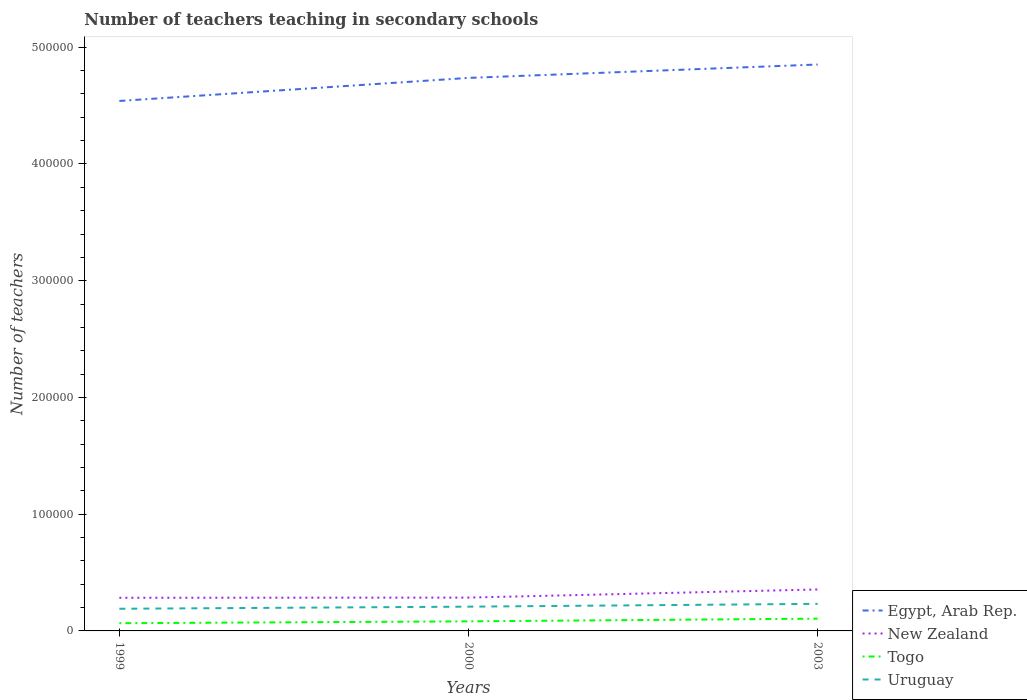How many different coloured lines are there?
Your answer should be compact. 4. Does the line corresponding to Togo intersect with the line corresponding to New Zealand?
Provide a succinct answer. No. Is the number of lines equal to the number of legend labels?
Your answer should be very brief. Yes. Across all years, what is the maximum number of teachers teaching in secondary schools in Togo?
Ensure brevity in your answer.  6595. In which year was the number of teachers teaching in secondary schools in New Zealand maximum?
Give a very brief answer. 1999. What is the total number of teachers teaching in secondary schools in Togo in the graph?
Your response must be concise. -1608. What is the difference between the highest and the second highest number of teachers teaching in secondary schools in Uruguay?
Offer a very short reply. 4207. Is the number of teachers teaching in secondary schools in Uruguay strictly greater than the number of teachers teaching in secondary schools in New Zealand over the years?
Provide a succinct answer. Yes. How many years are there in the graph?
Your answer should be compact. 3. What is the difference between two consecutive major ticks on the Y-axis?
Make the answer very short. 1.00e+05. Are the values on the major ticks of Y-axis written in scientific E-notation?
Your response must be concise. No. Does the graph contain any zero values?
Offer a terse response. No. Does the graph contain grids?
Offer a very short reply. No. How many legend labels are there?
Your answer should be compact. 4. How are the legend labels stacked?
Ensure brevity in your answer.  Vertical. What is the title of the graph?
Your answer should be very brief. Number of teachers teaching in secondary schools. What is the label or title of the X-axis?
Offer a terse response. Years. What is the label or title of the Y-axis?
Your response must be concise. Number of teachers. What is the Number of teachers of Egypt, Arab Rep. in 1999?
Ensure brevity in your answer.  4.54e+05. What is the Number of teachers in New Zealand in 1999?
Make the answer very short. 2.84e+04. What is the Number of teachers of Togo in 1999?
Ensure brevity in your answer.  6595. What is the Number of teachers in Uruguay in 1999?
Ensure brevity in your answer.  1.90e+04. What is the Number of teachers of Egypt, Arab Rep. in 2000?
Make the answer very short. 4.74e+05. What is the Number of teachers in New Zealand in 2000?
Make the answer very short. 2.85e+04. What is the Number of teachers of Togo in 2000?
Your answer should be compact. 8203. What is the Number of teachers of Uruguay in 2000?
Your response must be concise. 2.08e+04. What is the Number of teachers in Egypt, Arab Rep. in 2003?
Your response must be concise. 4.85e+05. What is the Number of teachers of New Zealand in 2003?
Provide a succinct answer. 3.55e+04. What is the Number of teachers in Togo in 2003?
Your answer should be compact. 1.05e+04. What is the Number of teachers of Uruguay in 2003?
Your answer should be compact. 2.32e+04. Across all years, what is the maximum Number of teachers of Egypt, Arab Rep.?
Offer a very short reply. 4.85e+05. Across all years, what is the maximum Number of teachers in New Zealand?
Provide a succinct answer. 3.55e+04. Across all years, what is the maximum Number of teachers of Togo?
Give a very brief answer. 1.05e+04. Across all years, what is the maximum Number of teachers of Uruguay?
Keep it short and to the point. 2.32e+04. Across all years, what is the minimum Number of teachers in Egypt, Arab Rep.?
Offer a very short reply. 4.54e+05. Across all years, what is the minimum Number of teachers in New Zealand?
Keep it short and to the point. 2.84e+04. Across all years, what is the minimum Number of teachers in Togo?
Ensure brevity in your answer.  6595. Across all years, what is the minimum Number of teachers in Uruguay?
Ensure brevity in your answer.  1.90e+04. What is the total Number of teachers of Egypt, Arab Rep. in the graph?
Keep it short and to the point. 1.41e+06. What is the total Number of teachers of New Zealand in the graph?
Keep it short and to the point. 9.24e+04. What is the total Number of teachers in Togo in the graph?
Your response must be concise. 2.53e+04. What is the total Number of teachers in Uruguay in the graph?
Your answer should be compact. 6.30e+04. What is the difference between the Number of teachers in Egypt, Arab Rep. in 1999 and that in 2000?
Keep it short and to the point. -1.97e+04. What is the difference between the Number of teachers in New Zealand in 1999 and that in 2000?
Keep it short and to the point. -157. What is the difference between the Number of teachers in Togo in 1999 and that in 2000?
Your answer should be very brief. -1608. What is the difference between the Number of teachers in Uruguay in 1999 and that in 2000?
Give a very brief answer. -1792. What is the difference between the Number of teachers of Egypt, Arab Rep. in 1999 and that in 2003?
Ensure brevity in your answer.  -3.12e+04. What is the difference between the Number of teachers of New Zealand in 1999 and that in 2003?
Give a very brief answer. -7118. What is the difference between the Number of teachers in Togo in 1999 and that in 2003?
Offer a terse response. -3918. What is the difference between the Number of teachers in Uruguay in 1999 and that in 2003?
Your answer should be very brief. -4207. What is the difference between the Number of teachers in Egypt, Arab Rep. in 2000 and that in 2003?
Your response must be concise. -1.15e+04. What is the difference between the Number of teachers in New Zealand in 2000 and that in 2003?
Ensure brevity in your answer.  -6961. What is the difference between the Number of teachers of Togo in 2000 and that in 2003?
Offer a terse response. -2310. What is the difference between the Number of teachers of Uruguay in 2000 and that in 2003?
Provide a short and direct response. -2415. What is the difference between the Number of teachers of Egypt, Arab Rep. in 1999 and the Number of teachers of New Zealand in 2000?
Your response must be concise. 4.25e+05. What is the difference between the Number of teachers in Egypt, Arab Rep. in 1999 and the Number of teachers in Togo in 2000?
Offer a terse response. 4.46e+05. What is the difference between the Number of teachers of Egypt, Arab Rep. in 1999 and the Number of teachers of Uruguay in 2000?
Offer a very short reply. 4.33e+05. What is the difference between the Number of teachers of New Zealand in 1999 and the Number of teachers of Togo in 2000?
Give a very brief answer. 2.02e+04. What is the difference between the Number of teachers of New Zealand in 1999 and the Number of teachers of Uruguay in 2000?
Ensure brevity in your answer.  7611. What is the difference between the Number of teachers in Togo in 1999 and the Number of teachers in Uruguay in 2000?
Offer a very short reply. -1.42e+04. What is the difference between the Number of teachers in Egypt, Arab Rep. in 1999 and the Number of teachers in New Zealand in 2003?
Offer a very short reply. 4.18e+05. What is the difference between the Number of teachers of Egypt, Arab Rep. in 1999 and the Number of teachers of Togo in 2003?
Offer a very short reply. 4.43e+05. What is the difference between the Number of teachers of Egypt, Arab Rep. in 1999 and the Number of teachers of Uruguay in 2003?
Provide a succinct answer. 4.31e+05. What is the difference between the Number of teachers in New Zealand in 1999 and the Number of teachers in Togo in 2003?
Ensure brevity in your answer.  1.79e+04. What is the difference between the Number of teachers in New Zealand in 1999 and the Number of teachers in Uruguay in 2003?
Make the answer very short. 5196. What is the difference between the Number of teachers in Togo in 1999 and the Number of teachers in Uruguay in 2003?
Offer a terse response. -1.66e+04. What is the difference between the Number of teachers of Egypt, Arab Rep. in 2000 and the Number of teachers of New Zealand in 2003?
Offer a very short reply. 4.38e+05. What is the difference between the Number of teachers of Egypt, Arab Rep. in 2000 and the Number of teachers of Togo in 2003?
Provide a succinct answer. 4.63e+05. What is the difference between the Number of teachers in Egypt, Arab Rep. in 2000 and the Number of teachers in Uruguay in 2003?
Offer a very short reply. 4.51e+05. What is the difference between the Number of teachers of New Zealand in 2000 and the Number of teachers of Togo in 2003?
Your response must be concise. 1.80e+04. What is the difference between the Number of teachers in New Zealand in 2000 and the Number of teachers in Uruguay in 2003?
Offer a terse response. 5353. What is the difference between the Number of teachers of Togo in 2000 and the Number of teachers of Uruguay in 2003?
Make the answer very short. -1.50e+04. What is the average Number of teachers of Egypt, Arab Rep. per year?
Your answer should be very brief. 4.71e+05. What is the average Number of teachers in New Zealand per year?
Your answer should be compact. 3.08e+04. What is the average Number of teachers of Togo per year?
Provide a short and direct response. 8437. What is the average Number of teachers of Uruguay per year?
Provide a short and direct response. 2.10e+04. In the year 1999, what is the difference between the Number of teachers in Egypt, Arab Rep. and Number of teachers in New Zealand?
Your answer should be compact. 4.26e+05. In the year 1999, what is the difference between the Number of teachers of Egypt, Arab Rep. and Number of teachers of Togo?
Provide a short and direct response. 4.47e+05. In the year 1999, what is the difference between the Number of teachers of Egypt, Arab Rep. and Number of teachers of Uruguay?
Keep it short and to the point. 4.35e+05. In the year 1999, what is the difference between the Number of teachers in New Zealand and Number of teachers in Togo?
Offer a very short reply. 2.18e+04. In the year 1999, what is the difference between the Number of teachers in New Zealand and Number of teachers in Uruguay?
Make the answer very short. 9403. In the year 1999, what is the difference between the Number of teachers in Togo and Number of teachers in Uruguay?
Your response must be concise. -1.24e+04. In the year 2000, what is the difference between the Number of teachers of Egypt, Arab Rep. and Number of teachers of New Zealand?
Give a very brief answer. 4.45e+05. In the year 2000, what is the difference between the Number of teachers of Egypt, Arab Rep. and Number of teachers of Togo?
Your answer should be compact. 4.66e+05. In the year 2000, what is the difference between the Number of teachers of Egypt, Arab Rep. and Number of teachers of Uruguay?
Your answer should be compact. 4.53e+05. In the year 2000, what is the difference between the Number of teachers in New Zealand and Number of teachers in Togo?
Keep it short and to the point. 2.03e+04. In the year 2000, what is the difference between the Number of teachers of New Zealand and Number of teachers of Uruguay?
Keep it short and to the point. 7768. In the year 2000, what is the difference between the Number of teachers in Togo and Number of teachers in Uruguay?
Offer a terse response. -1.26e+04. In the year 2003, what is the difference between the Number of teachers of Egypt, Arab Rep. and Number of teachers of New Zealand?
Your response must be concise. 4.50e+05. In the year 2003, what is the difference between the Number of teachers of Egypt, Arab Rep. and Number of teachers of Togo?
Offer a very short reply. 4.75e+05. In the year 2003, what is the difference between the Number of teachers in Egypt, Arab Rep. and Number of teachers in Uruguay?
Offer a very short reply. 4.62e+05. In the year 2003, what is the difference between the Number of teachers in New Zealand and Number of teachers in Togo?
Your response must be concise. 2.50e+04. In the year 2003, what is the difference between the Number of teachers of New Zealand and Number of teachers of Uruguay?
Your answer should be compact. 1.23e+04. In the year 2003, what is the difference between the Number of teachers of Togo and Number of teachers of Uruguay?
Your answer should be very brief. -1.27e+04. What is the ratio of the Number of teachers of Togo in 1999 to that in 2000?
Offer a very short reply. 0.8. What is the ratio of the Number of teachers in Uruguay in 1999 to that in 2000?
Ensure brevity in your answer.  0.91. What is the ratio of the Number of teachers of Egypt, Arab Rep. in 1999 to that in 2003?
Keep it short and to the point. 0.94. What is the ratio of the Number of teachers of New Zealand in 1999 to that in 2003?
Offer a very short reply. 0.8. What is the ratio of the Number of teachers of Togo in 1999 to that in 2003?
Offer a terse response. 0.63. What is the ratio of the Number of teachers in Uruguay in 1999 to that in 2003?
Make the answer very short. 0.82. What is the ratio of the Number of teachers in Egypt, Arab Rep. in 2000 to that in 2003?
Keep it short and to the point. 0.98. What is the ratio of the Number of teachers in New Zealand in 2000 to that in 2003?
Provide a succinct answer. 0.8. What is the ratio of the Number of teachers of Togo in 2000 to that in 2003?
Your response must be concise. 0.78. What is the ratio of the Number of teachers of Uruguay in 2000 to that in 2003?
Provide a succinct answer. 0.9. What is the difference between the highest and the second highest Number of teachers of Egypt, Arab Rep.?
Keep it short and to the point. 1.15e+04. What is the difference between the highest and the second highest Number of teachers of New Zealand?
Give a very brief answer. 6961. What is the difference between the highest and the second highest Number of teachers of Togo?
Your response must be concise. 2310. What is the difference between the highest and the second highest Number of teachers in Uruguay?
Provide a succinct answer. 2415. What is the difference between the highest and the lowest Number of teachers of Egypt, Arab Rep.?
Offer a very short reply. 3.12e+04. What is the difference between the highest and the lowest Number of teachers in New Zealand?
Offer a terse response. 7118. What is the difference between the highest and the lowest Number of teachers in Togo?
Offer a terse response. 3918. What is the difference between the highest and the lowest Number of teachers in Uruguay?
Give a very brief answer. 4207. 